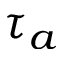Convert formula to latex. <formula><loc_0><loc_0><loc_500><loc_500>\tau { _ { a } }</formula> 